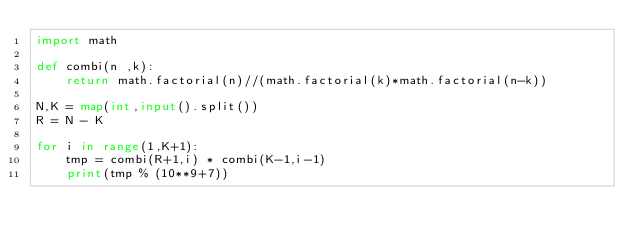<code> <loc_0><loc_0><loc_500><loc_500><_Python_>import math

def combi(n ,k):
    return math.factorial(n)//(math.factorial(k)*math.factorial(n-k))

N,K = map(int,input().split())
R = N - K

for i in range(1,K+1):
    tmp = combi(R+1,i) * combi(K-1,i-1)
    print(tmp % (10**9+7))</code> 